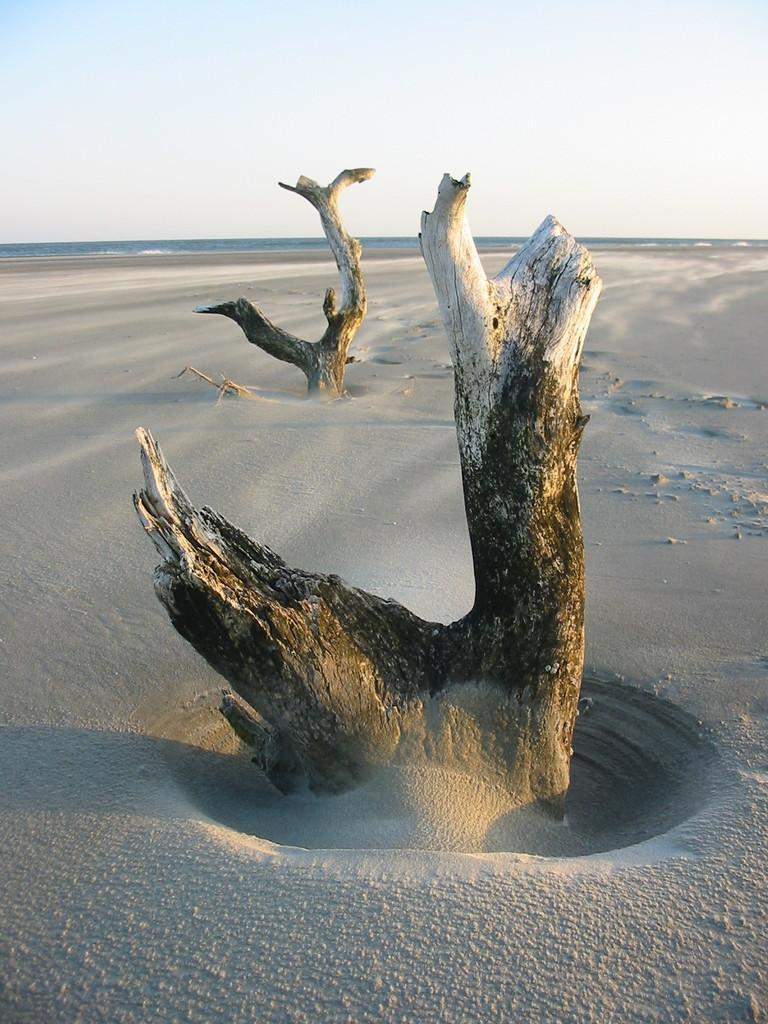What type of terrain is depicted in the image? There is sand in the image. What other natural elements can be seen in the image? There are trunks of trees in the image. What can be seen in the distance in the image? There is water visible in the background of the image. How would you describe the weather based on the image? The sky is clear in the background of the image, suggesting good weather. Where is the scarecrow located in the image? There is no scarecrow present in the image. How many drops of water can be seen in the image? There are no drops of water visible in the image. 